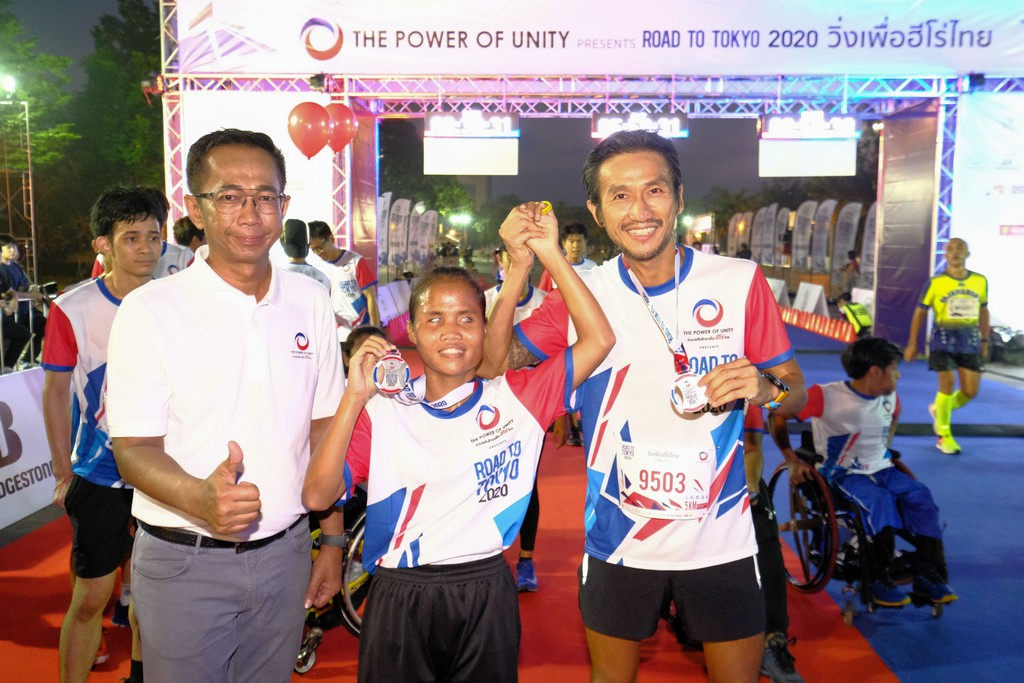Considering the attire and medals of the participants, along with the "ROAD TO TOKYO 2020" banner, what might be the significance of this event and how does it reflect the broader context of the Olympic spirit? The event appears to be a celebratory race leading up to the Tokyo 2020 Olympics, likely organized to foster unity and the Olympic spirit among participants. The presence of runners of varied heights and abilities, including a person in a wheelchair, reflects the inclusiveness and camaraderie central to the Olympic values. The event promotes physical activity and celebrates the achievement of all participants, embodying the Olympic spirit of bringing people together through sport. 